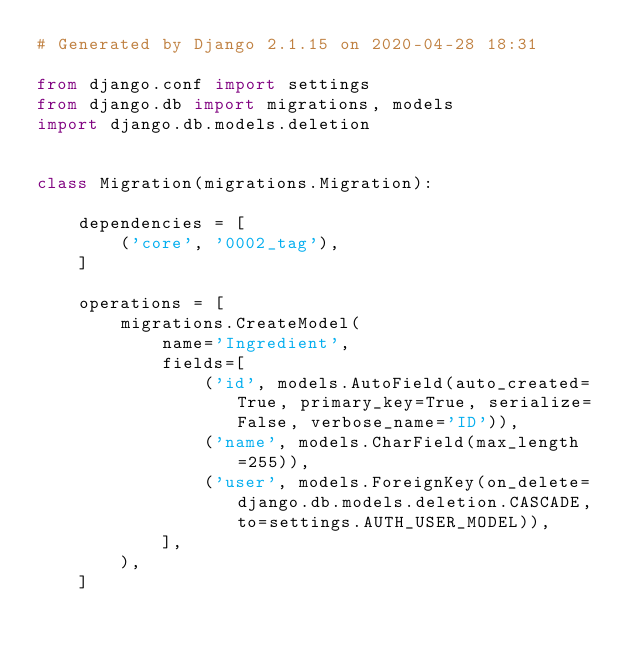<code> <loc_0><loc_0><loc_500><loc_500><_Python_># Generated by Django 2.1.15 on 2020-04-28 18:31

from django.conf import settings
from django.db import migrations, models
import django.db.models.deletion


class Migration(migrations.Migration):

    dependencies = [
        ('core', '0002_tag'),
    ]

    operations = [
        migrations.CreateModel(
            name='Ingredient',
            fields=[
                ('id', models.AutoField(auto_created=True, primary_key=True, serialize=False, verbose_name='ID')),
                ('name', models.CharField(max_length=255)),
                ('user', models.ForeignKey(on_delete=django.db.models.deletion.CASCADE, to=settings.AUTH_USER_MODEL)),
            ],
        ),
    ]
</code> 